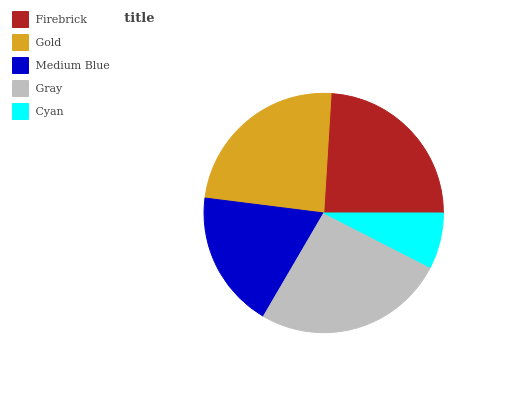Is Cyan the minimum?
Answer yes or no. Yes. Is Gray the maximum?
Answer yes or no. Yes. Is Gold the minimum?
Answer yes or no. No. Is Gold the maximum?
Answer yes or no. No. Is Firebrick greater than Gold?
Answer yes or no. Yes. Is Gold less than Firebrick?
Answer yes or no. Yes. Is Gold greater than Firebrick?
Answer yes or no. No. Is Firebrick less than Gold?
Answer yes or no. No. Is Gold the high median?
Answer yes or no. Yes. Is Gold the low median?
Answer yes or no. Yes. Is Gray the high median?
Answer yes or no. No. Is Cyan the low median?
Answer yes or no. No. 